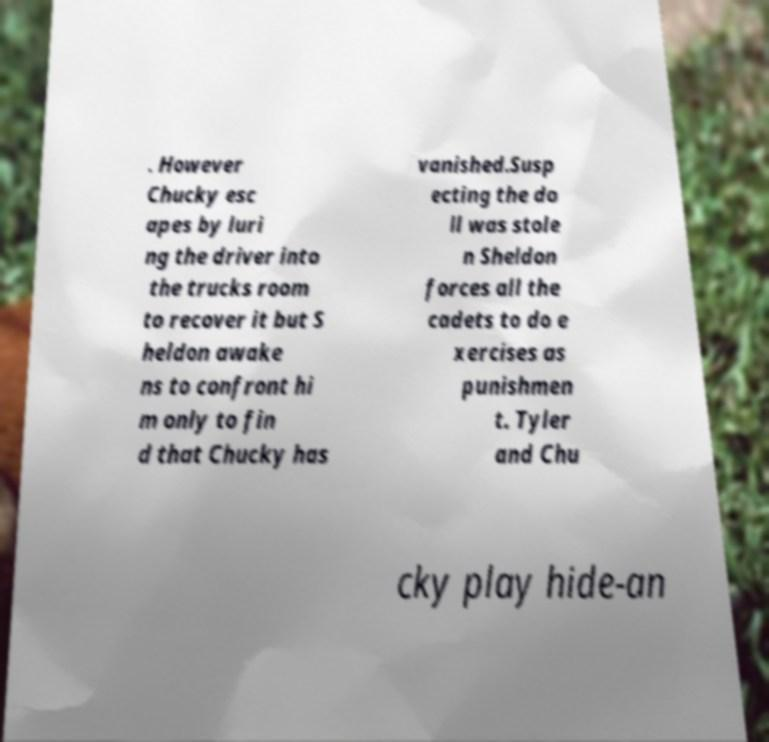Could you assist in decoding the text presented in this image and type it out clearly? . However Chucky esc apes by luri ng the driver into the trucks room to recover it but S heldon awake ns to confront hi m only to fin d that Chucky has vanished.Susp ecting the do ll was stole n Sheldon forces all the cadets to do e xercises as punishmen t. Tyler and Chu cky play hide-an 